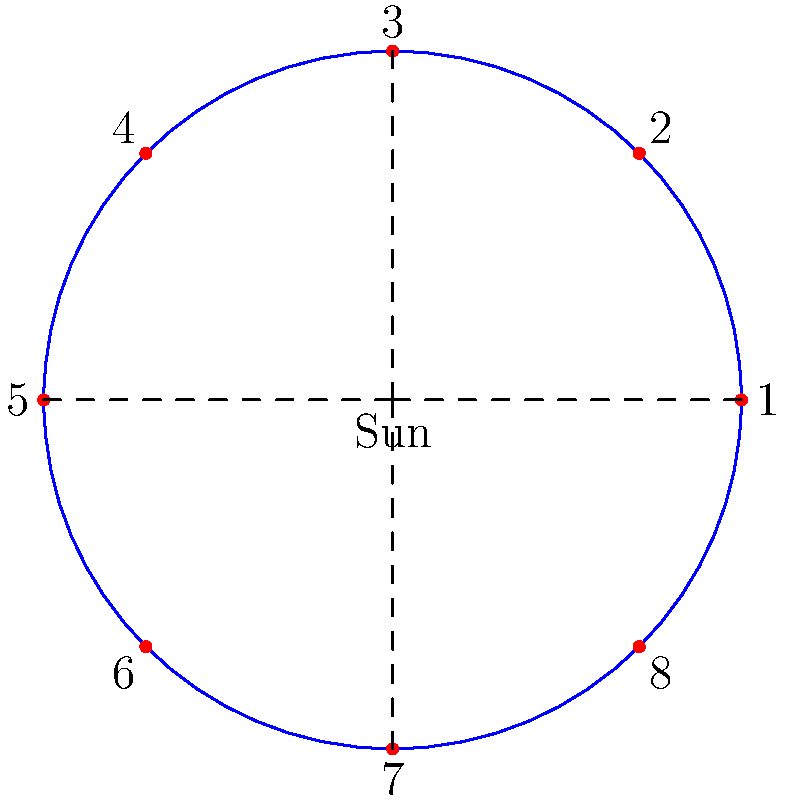In this simplified model of our solar system, the Sun is at the center and the planets are represented by numbered dots. If Earth is typically considered the third planet from the Sun, which number would most likely represent Earth in this model? To answer this question, we need to follow these steps:

1. Understand the model: The diagram shows a simplified solar system with the Sun at the center and 8 dots representing planets.

2. Recall Earth's position: Earth is generally known as the third planet from the Sun.

3. Count from the Sun: In this model, we should start counting from the dot closest to the right side of the Sun (traditionally considered the starting point) and move counterclockwise.

4. Identify Earth: The third dot we count would represent Earth.

5. Find the number: Looking at the diagram, we can see that the third dot is labeled with the number 3.

This approach aligns with the real solar system order: Mercury (1), Venus (2), Earth (3), Mars (4), Jupiter (5), Saturn (6), Uranus (7), and Neptune (8).
Answer: 3 